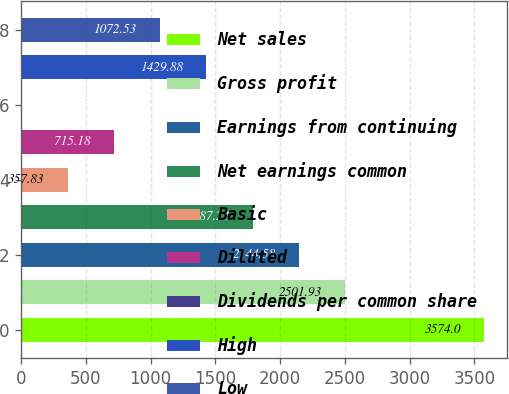<chart> <loc_0><loc_0><loc_500><loc_500><bar_chart><fcel>Net sales<fcel>Gross profit<fcel>Earnings from continuing<fcel>Net earnings common<fcel>Basic<fcel>Diluted<fcel>Dividends per common share<fcel>High<fcel>Low<nl><fcel>3574<fcel>2501.93<fcel>2144.58<fcel>1787.23<fcel>357.83<fcel>715.18<fcel>0.48<fcel>1429.88<fcel>1072.53<nl></chart> 